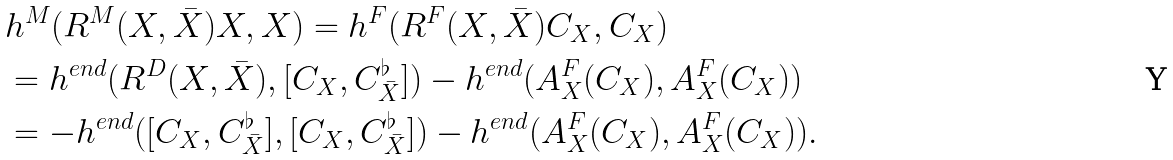Convert formula to latex. <formula><loc_0><loc_0><loc_500><loc_500>& h ^ { M } ( R ^ { M } ( X , \bar { X } ) X , X ) = h ^ { F } ( R ^ { F } ( X , \bar { X } ) C _ { X } , C _ { X } ) \\ & = h ^ { e n d } ( R ^ { D } ( X , \bar { X } ) , [ C _ { X } , C _ { \bar { X } } ^ { \flat } ] ) - h ^ { e n d } ( A ^ { F } _ { X } ( C _ { X } ) , A ^ { F } _ { X } ( C _ { X } ) ) \\ & = - h ^ { e n d } ( [ C _ { X } , C _ { \bar { X } } ^ { \flat } ] , [ C _ { X } , C _ { \bar { X } } ^ { \flat } ] ) - h ^ { e n d } ( A ^ { F } _ { X } ( C _ { X } ) , A ^ { F } _ { X } ( C _ { X } ) ) .</formula> 